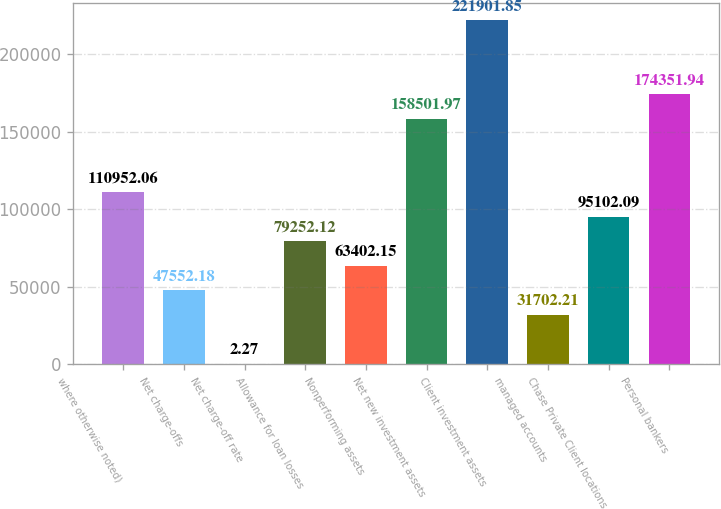Convert chart to OTSL. <chart><loc_0><loc_0><loc_500><loc_500><bar_chart><fcel>where otherwise noted)<fcel>Net charge-offs<fcel>Net charge-off rate<fcel>Allowance for loan losses<fcel>Nonperforming assets<fcel>Net new investment assets<fcel>Client investment assets<fcel>managed accounts<fcel>Chase Private Client locations<fcel>Personal bankers<nl><fcel>110952<fcel>47552.2<fcel>2.27<fcel>79252.1<fcel>63402.2<fcel>158502<fcel>221902<fcel>31702.2<fcel>95102.1<fcel>174352<nl></chart> 